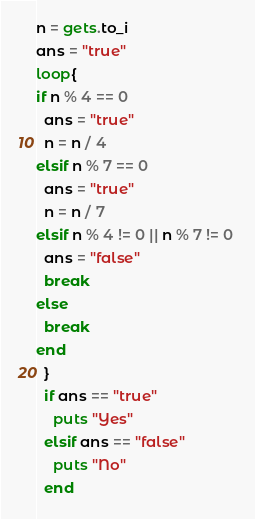Convert code to text. <code><loc_0><loc_0><loc_500><loc_500><_Ruby_>n = gets.to_i
ans = "true"
loop{
if n % 4 == 0 
  ans = "true"
  n = n / 4
elsif n % 7 == 0
  ans = "true"
  n = n / 7
elsif n % 4 != 0 || n % 7 != 0 
  ans = "false"
  break
else
  break
end
  }
  if ans == "true"
    puts "Yes"
  elsif ans == "false"
    puts "No"
  end</code> 